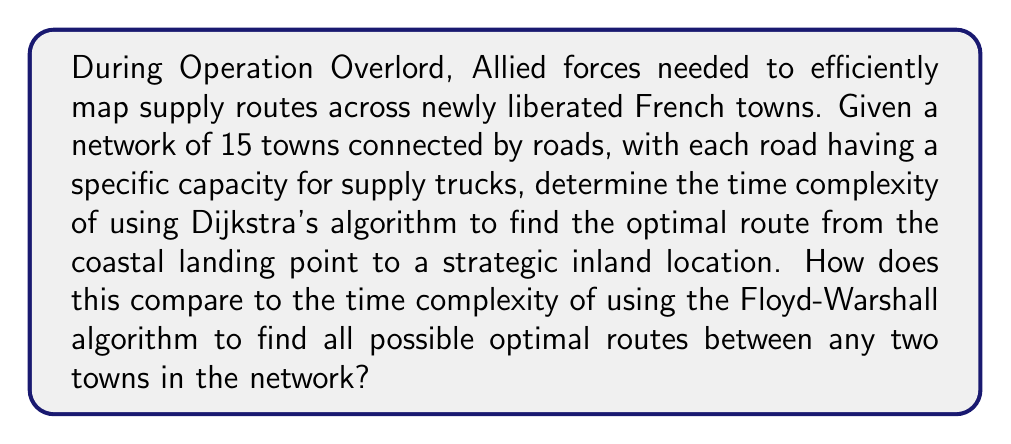Can you answer this question? To solve this problem, we need to consider the time complexities of Dijkstra's algorithm and the Floyd-Warshall algorithm:

1. Dijkstra's Algorithm:
   - Used for finding the shortest path from a single source to all other vertices in a weighted graph.
   - Time complexity: $$O((V + E) \log V)$$ with a binary heap implementation, where $V$ is the number of vertices (towns) and $E$ is the number of edges (roads).
   - In this case, $V = 15$ (towns)

2. Floyd-Warshall Algorithm:
   - Used for finding all-pairs shortest paths in a weighted graph.
   - Time complexity: $$O(V^3)$$, where $V$ is the number of vertices (towns).

For Dijkstra's algorithm:
- Worst-case scenario for edges in a complete graph: $$E = \frac{V(V-1)}{2} = \frac{15(14)}{2} = 105$$
- Time complexity: $$O((15 + 105) \log 15) = O(120 \log 15) \approx O(120 \times 3.91) \approx O(469.2)$$

For Floyd-Warshall algorithm:
- Time complexity: $$O(15^3) = O(3375)$$

The ratio of Floyd-Warshall to Dijkstra's time complexity:
$$\frac{3375}{469.2} \approx 7.19$$

This means the Floyd-Warshall algorithm would take approximately 7.19 times longer to run than Dijkstra's algorithm for this specific scenario.
Answer: Dijkstra's algorithm time complexity: $$O((V + E) \log V) \approx O(469.2)$$
Floyd-Warshall algorithm time complexity: $$O(V^3) = O(3375)$$
Floyd-Warshall is approximately 7.19 times slower than Dijkstra's for this scenario. 